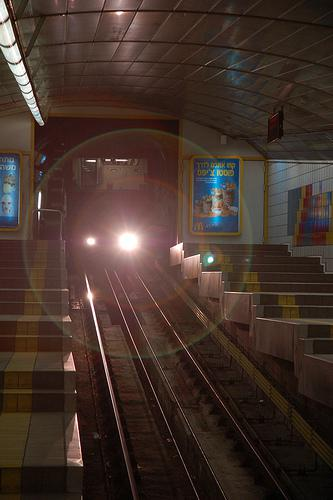Question: where was the picture taken?
Choices:
A. In the park.
B. Outside.
C. At train station.
D. By the lake.
Answer with the letter. Answer: C Question: what color is the ceiling?
Choices:
A. White.
B. Black.
C. Blue.
D. Gray.
Answer with the letter. Answer: D Question: why is the train light on?
Choices:
A. The train is moving.
B. It is ready to go.
C. It is dark.
D. It is raining.
Answer with the letter. Answer: C Question: what is on the ground?
Choices:
A. The track.
B. Flowers.
C. Grass.
D. A ball.
Answer with the letter. Answer: A 